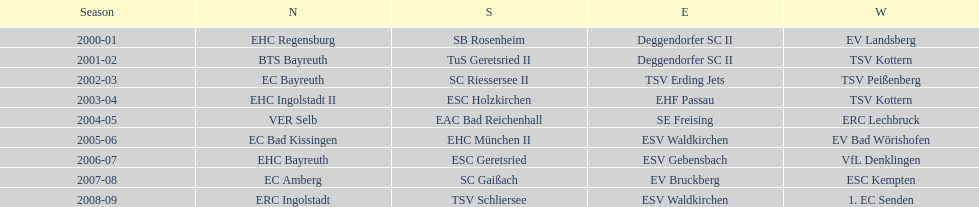What was the first club for the north in the 2000's? EHC Regensburg. 